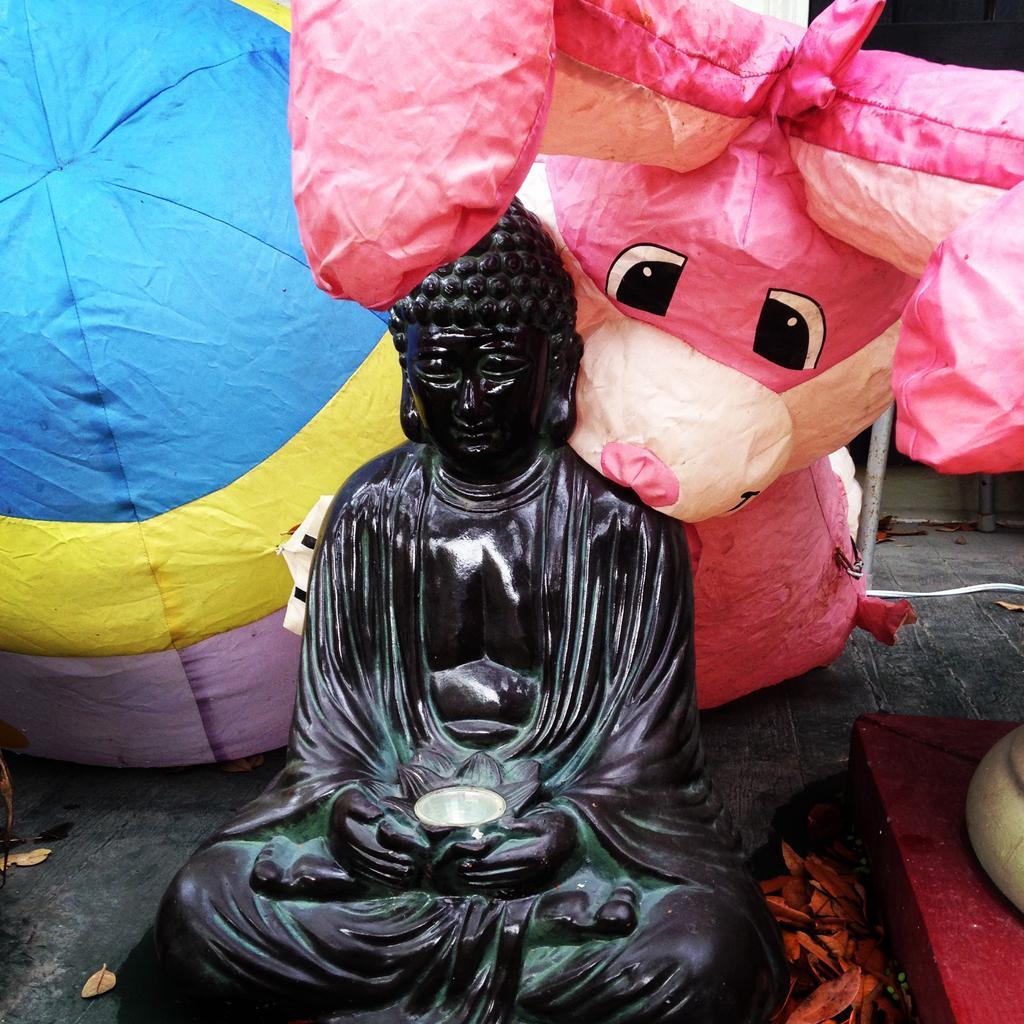Describe this image in one or two sentences. In the center of the image we can see the sculpture. we can also see the balloon toys, rods, dried leaves, path and also some other object on the right. 